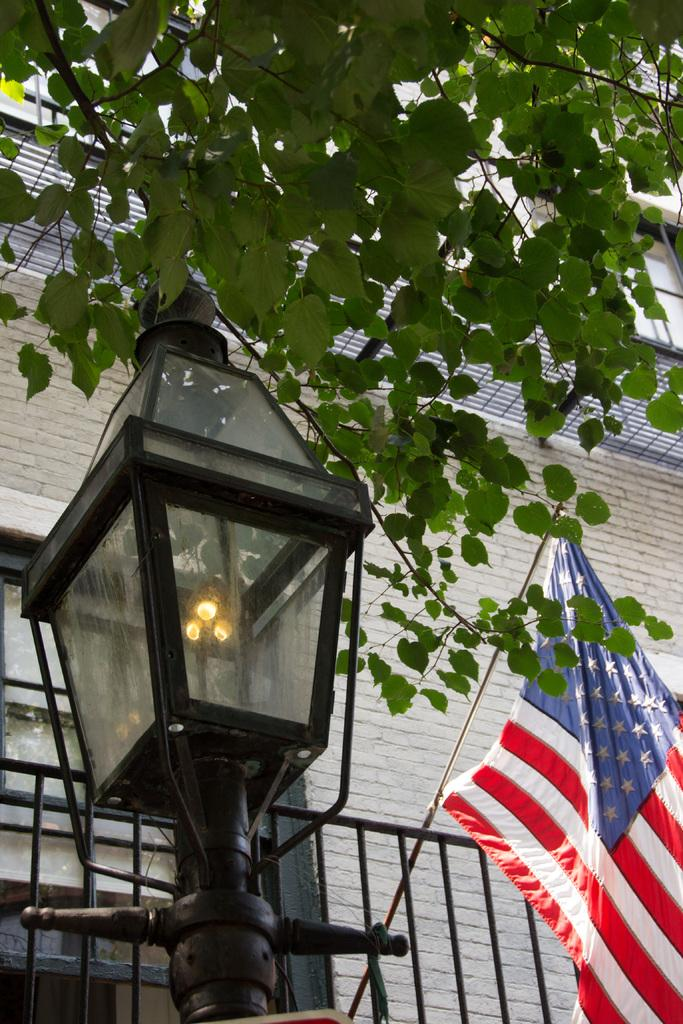What type of illumination source is present in the image? There is a light in the image. What national symbol can be seen in the image? There is a flag in the image. What type of plant is visible in the image? There is a tree in the image. What type of structure is present in the image? There is a building in the image. What type of material is used for the rods in the image? There are metal rods in the image. Can you tell me how many dogs are involved in the argument in the image? There is no argument or dogs present in the image. 